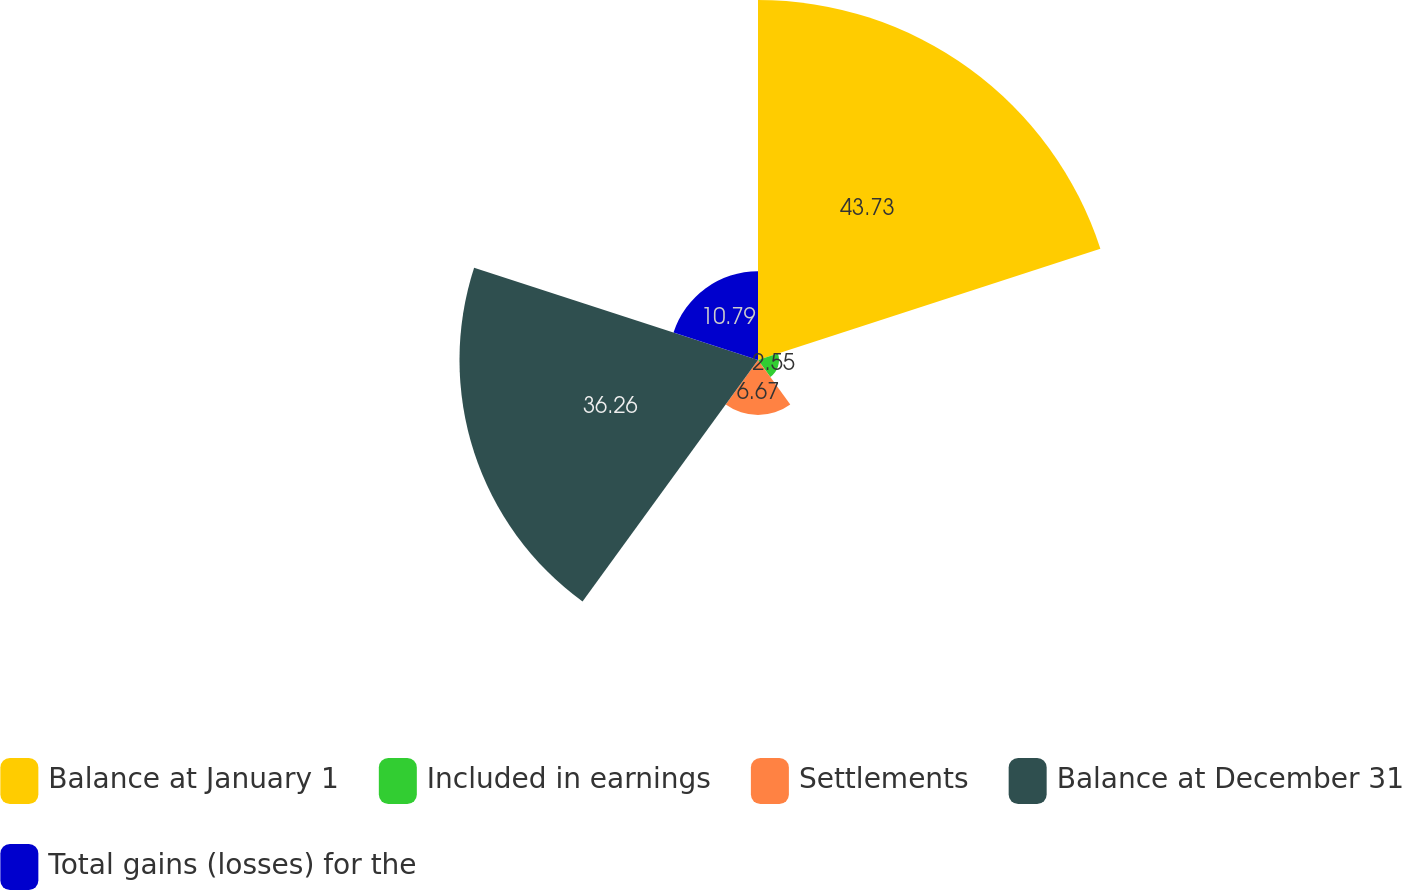Convert chart to OTSL. <chart><loc_0><loc_0><loc_500><loc_500><pie_chart><fcel>Balance at January 1<fcel>Included in earnings<fcel>Settlements<fcel>Balance at December 31<fcel>Total gains (losses) for the<nl><fcel>43.73%<fcel>2.55%<fcel>6.67%<fcel>36.26%<fcel>10.79%<nl></chart> 